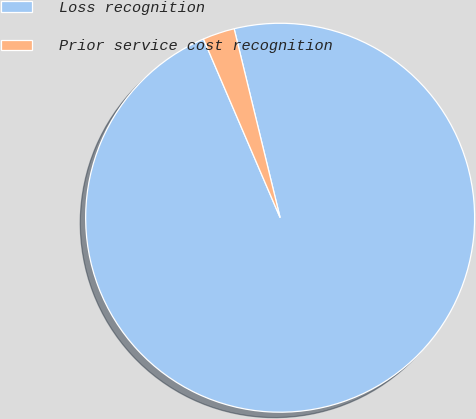Convert chart to OTSL. <chart><loc_0><loc_0><loc_500><loc_500><pie_chart><fcel>Loss recognition<fcel>Prior service cost recognition<nl><fcel>97.35%<fcel>2.65%<nl></chart> 